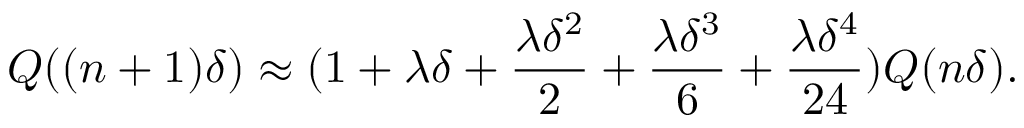Convert formula to latex. <formula><loc_0><loc_0><loc_500><loc_500>Q ( ( n + 1 ) \delta ) \approx ( 1 + \lambda \delta + \frac { \lambda \delta ^ { 2 } } { 2 } + \frac { \lambda \delta ^ { 3 } } { 6 } + \frac { \lambda \delta ^ { 4 } } { 2 4 } ) Q ( n \delta ) .</formula> 